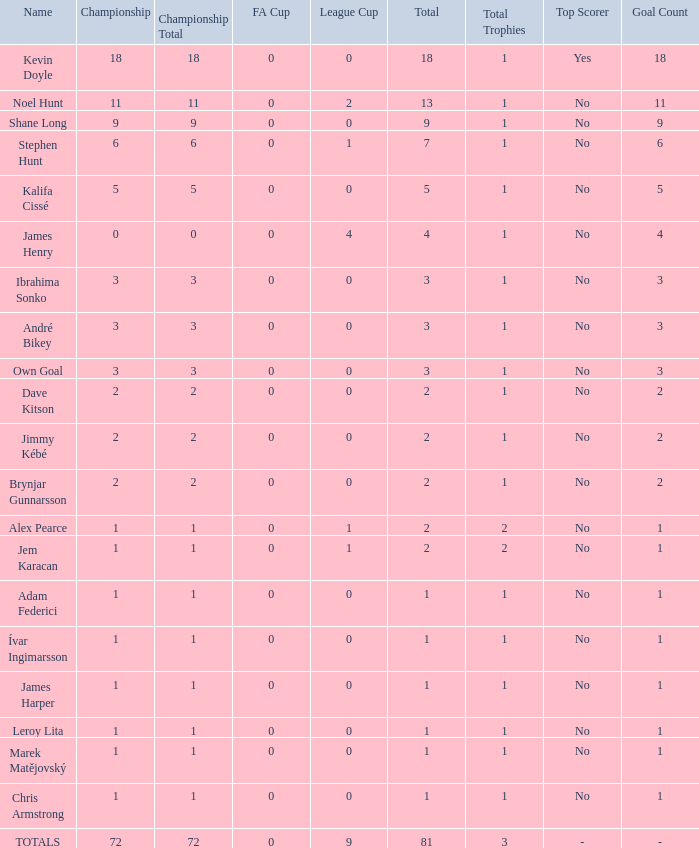What is the total championships that the league cup is less than 0? None. 